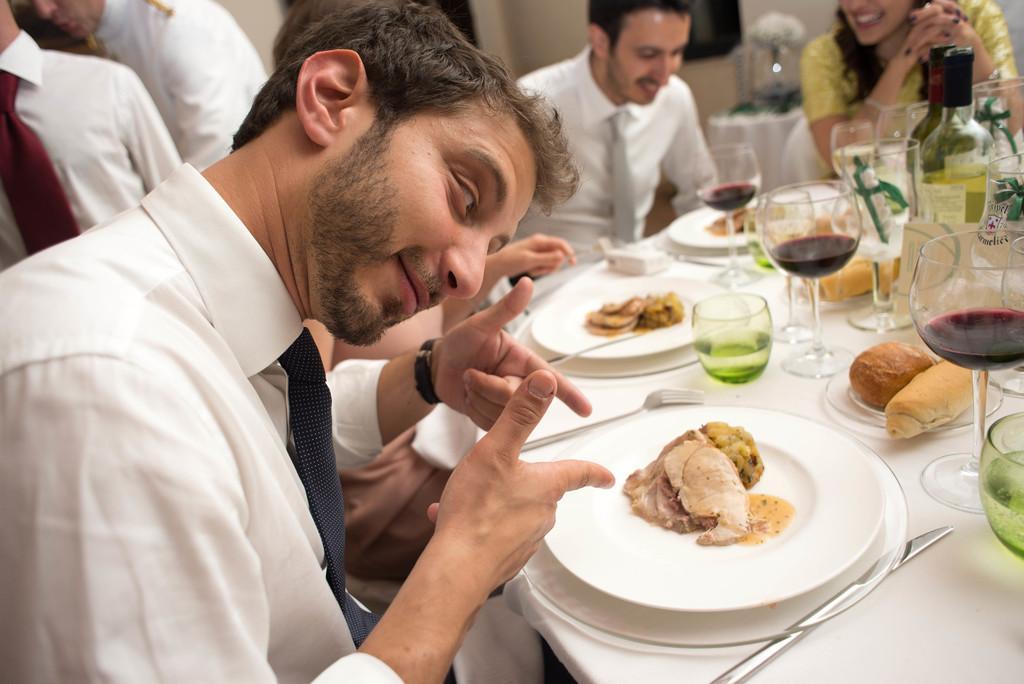Can you describe this image briefly? This picture is taken inside the room. In this image, we can see a group of people sitting on the chair in front of the table. On the table, we can see a white colored cloth, knife, plate with some food, fork, glass with some drink, which is in green color and a glass with some drink which is in red color, bottle. On the left side, we can see two men. In the background, we can see a wall. 